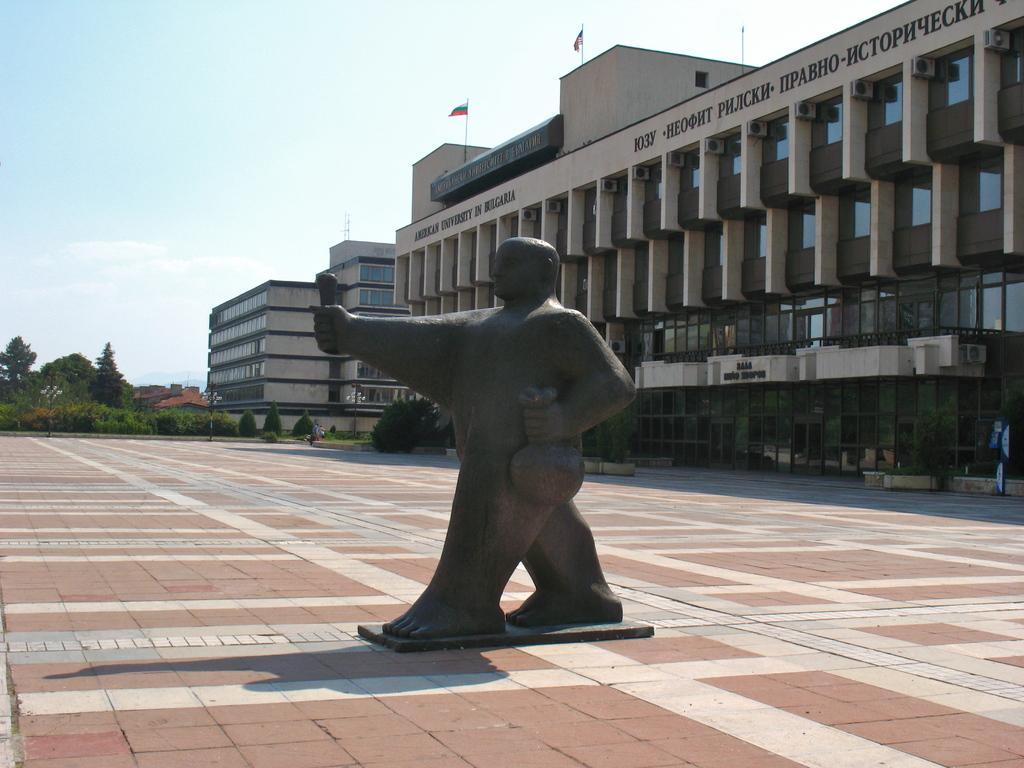Describe this image in one or two sentences. In the center of the image there is a statue. To the right side of the image there is a building and flags on it. In the background of the image there are trees,buildings and sky. At the bottom of the image there is floor. 